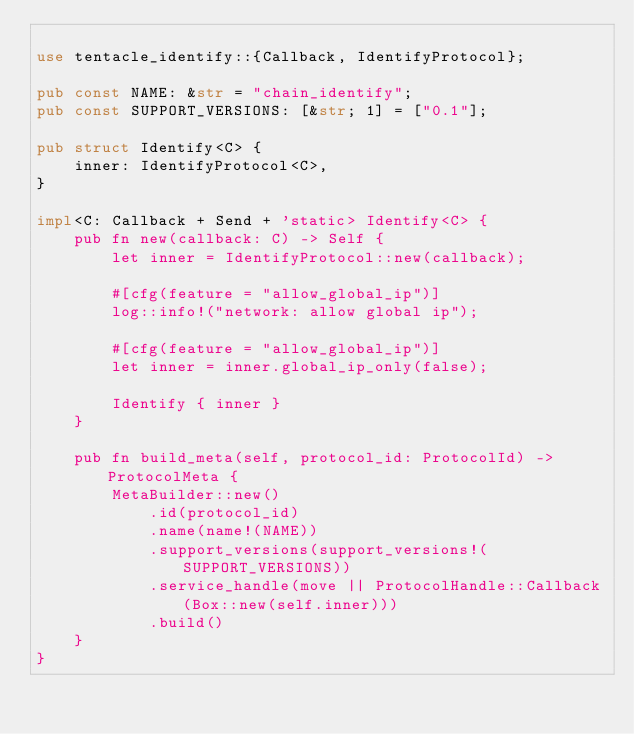Convert code to text. <code><loc_0><loc_0><loc_500><loc_500><_Rust_>
use tentacle_identify::{Callback, IdentifyProtocol};

pub const NAME: &str = "chain_identify";
pub const SUPPORT_VERSIONS: [&str; 1] = ["0.1"];

pub struct Identify<C> {
    inner: IdentifyProtocol<C>,
}

impl<C: Callback + Send + 'static> Identify<C> {
    pub fn new(callback: C) -> Self {
        let inner = IdentifyProtocol::new(callback);

        #[cfg(feature = "allow_global_ip")]
        log::info!("network: allow global ip");

        #[cfg(feature = "allow_global_ip")]
        let inner = inner.global_ip_only(false);

        Identify { inner }
    }

    pub fn build_meta(self, protocol_id: ProtocolId) -> ProtocolMeta {
        MetaBuilder::new()
            .id(protocol_id)
            .name(name!(NAME))
            .support_versions(support_versions!(SUPPORT_VERSIONS))
            .service_handle(move || ProtocolHandle::Callback(Box::new(self.inner)))
            .build()
    }
}
</code> 